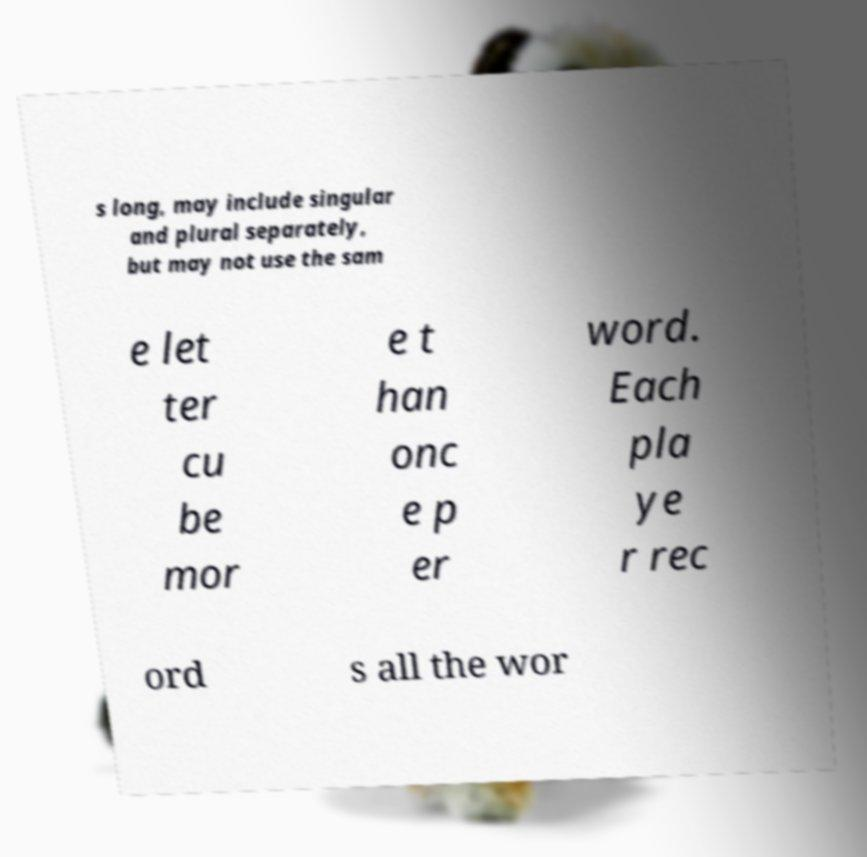Please read and relay the text visible in this image. What does it say? s long, may include singular and plural separately, but may not use the sam e let ter cu be mor e t han onc e p er word. Each pla ye r rec ord s all the wor 